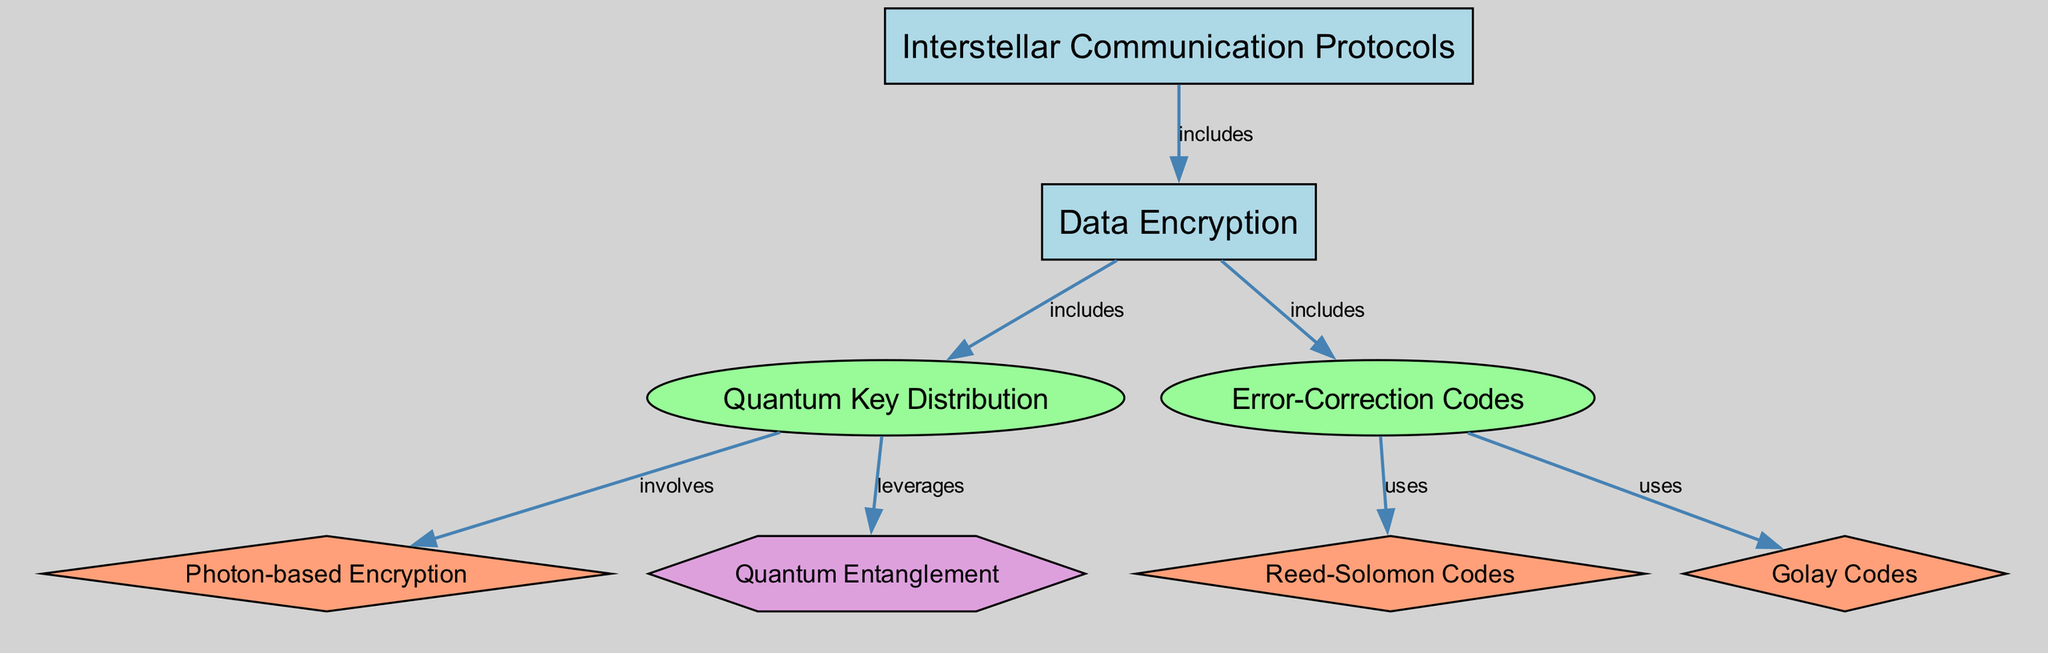What is the main category of this diagram? The diagram consists of a top-level category labeled "Interstellar Communication Protocols," which encompasses the subject matter of the diagram.
Answer: Interstellar Communication Protocols How many sub-categories are included under Data Encryption? Under the "Data Encryption" category, there are two sub-categories listed: "Quantum Key Distribution" and "Error-Correction Codes," so the total count is two.
Answer: 2 What method is involved in Quantum Key Distribution? The diagram shows that "Photon-based Encryption" is a method that is specifically involved in the "Quantum Key Distribution" sub-category.
Answer: Photon-based Encryption Which concept does Quantum Key Distribution leverage? The diagram indicates that "Quantum Entanglement" is a concept that is leveraged by "Quantum Key Distribution," highlighting the relationship between these elements.
Answer: Quantum Entanglement What methods are used in Error-Correction Codes? The diagram specifies that both "Reed-Solomon Codes" and "Golay Codes" are methods used under the "Error-Correction Codes" sub-category. Thus, the answer includes these two methods.
Answer: Reed-Solomon Codes, Golay Codes How many total nodes are in the diagram? By counting all the nodes presented, including categories, sub-categories, methods, and concepts, there are a total of eight nodes in the diagram.
Answer: 8 What type of relationship exists between the nodes "Data Encryption" and "Quantum Key Distribution"? The diagram shows that "Data Encryption" includes "Quantum Key Distribution," indicating a hierarchical relationship where the latter is a part of the former.
Answer: includes What are the two types of methods listed under Error-Correction Codes? The diagram highlights the two methods under "Error-Correction Codes," which are "Reed-Solomon Codes" and "Golay Codes," indicating that both are categorized together.
Answer: Reed-Solomon Codes, Golay Codes Which node is a category that includes sub-categories and methods? The "Data Encryption" node acts as a category that includes both the sub-categories and methods specified in the diagram, serving as a central node for these elements.
Answer: Data Encryption 